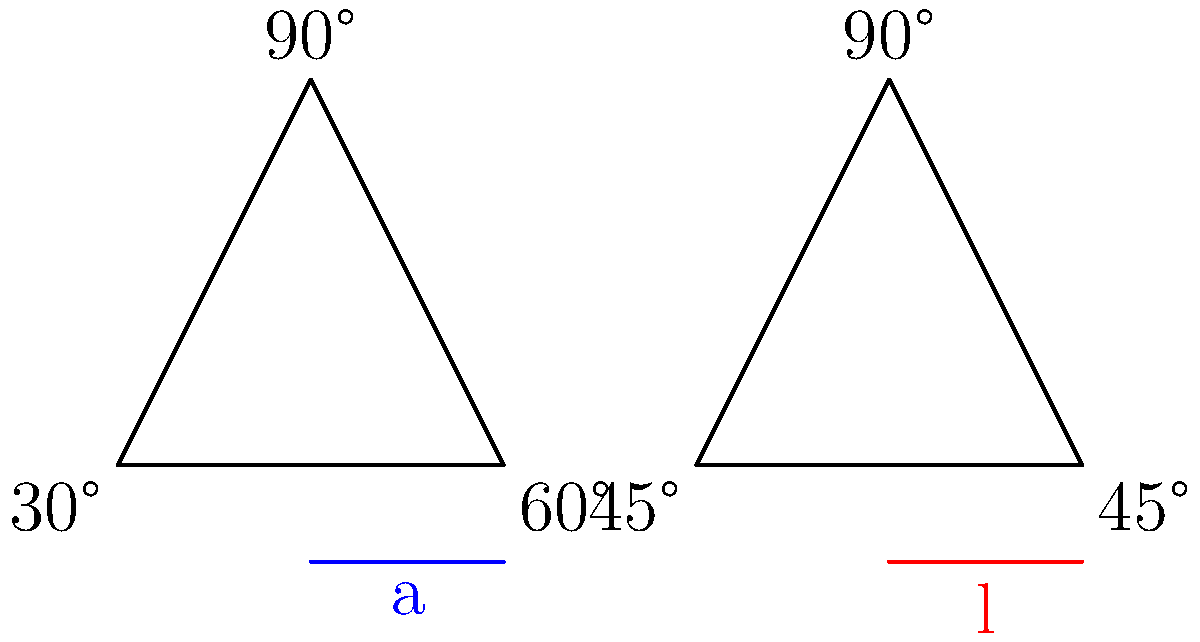As a pediatric therapist helping children develop handwriting skills, you're teaching about the relationship between angles and letter formation. Which letter shown in the diagram corresponds to the triangle with two 45° angles? To answer this question, let's analyze the given information step-by-step:

1. We are presented with two triangles in the diagram.

2. The first triangle (on the left) has angles of 30°, 60°, and 90°.

3. The second triangle (on the right) has angles of 45°, 45°, and 90°.

4. Below each triangle, there's a letter drawn:
   - Under the 30-60-90 triangle, we see the letter "a"
   - Under the 45-45-90 triangle, we see the letter "l"

5. The question asks about the triangle with two 45° angles.

6. We can identify that the triangle on the right has two 45° angles.

7. The letter shown below this triangle is "l".

Therefore, the letter that corresponds to the triangle with two 45° angles is "l".

This relationship is important in handwriting because the angle of the pencil and the angles formed in letter shapes can affect legibility and ease of writing. The straight line of the lowercase "l" often forms a 45° angle with the baseline, which corresponds to the 45° angles in the triangle.
Answer: l 